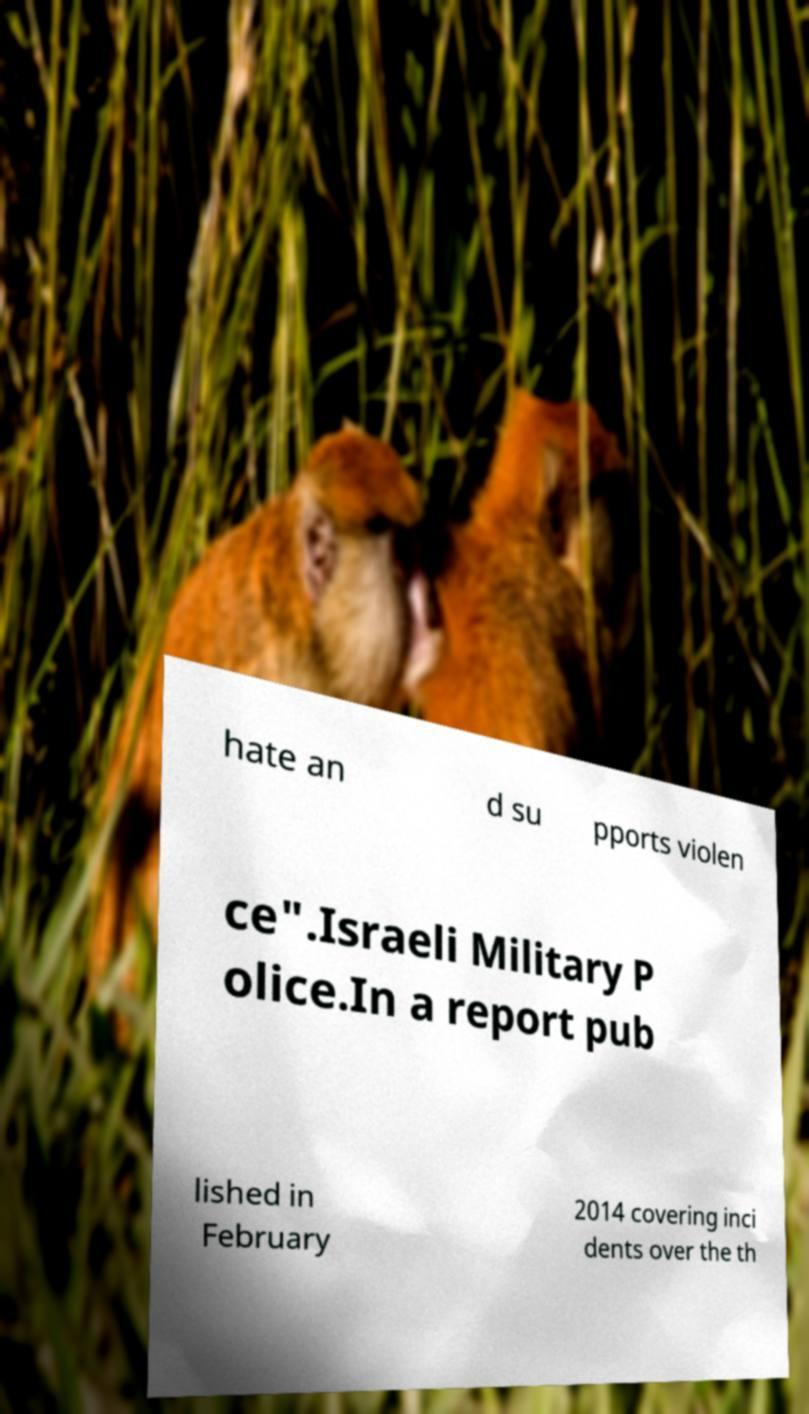Can you accurately transcribe the text from the provided image for me? hate an d su pports violen ce".Israeli Military P olice.In a report pub lished in February 2014 covering inci dents over the th 